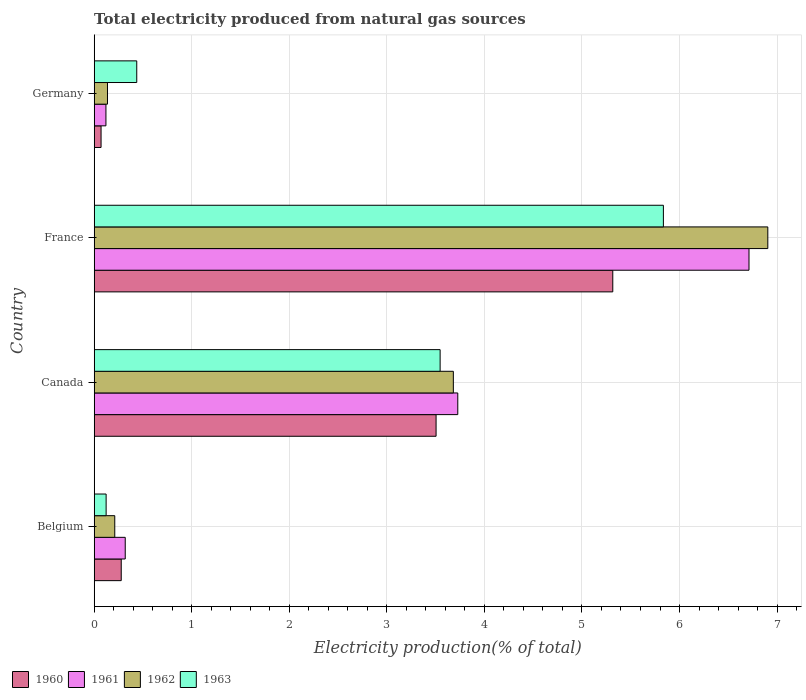Are the number of bars per tick equal to the number of legend labels?
Give a very brief answer. Yes. Are the number of bars on each tick of the Y-axis equal?
Provide a short and direct response. Yes. How many bars are there on the 3rd tick from the top?
Provide a short and direct response. 4. What is the total electricity produced in 1960 in Belgium?
Your answer should be very brief. 0.28. Across all countries, what is the maximum total electricity produced in 1960?
Your answer should be very brief. 5.32. Across all countries, what is the minimum total electricity produced in 1961?
Give a very brief answer. 0.12. In which country was the total electricity produced in 1961 maximum?
Give a very brief answer. France. In which country was the total electricity produced in 1963 minimum?
Keep it short and to the point. Belgium. What is the total total electricity produced in 1963 in the graph?
Make the answer very short. 9.94. What is the difference between the total electricity produced in 1960 in Belgium and that in Canada?
Keep it short and to the point. -3.23. What is the difference between the total electricity produced in 1961 in France and the total electricity produced in 1963 in Canada?
Make the answer very short. 3.17. What is the average total electricity produced in 1960 per country?
Your response must be concise. 2.29. What is the difference between the total electricity produced in 1961 and total electricity produced in 1960 in Germany?
Provide a succinct answer. 0.05. What is the ratio of the total electricity produced in 1962 in Belgium to that in Canada?
Provide a succinct answer. 0.06. What is the difference between the highest and the second highest total electricity produced in 1960?
Provide a succinct answer. 1.81. What is the difference between the highest and the lowest total electricity produced in 1960?
Ensure brevity in your answer.  5.25. Is the sum of the total electricity produced in 1962 in Canada and Germany greater than the maximum total electricity produced in 1960 across all countries?
Ensure brevity in your answer.  No. Is it the case that in every country, the sum of the total electricity produced in 1960 and total electricity produced in 1961 is greater than the sum of total electricity produced in 1962 and total electricity produced in 1963?
Keep it short and to the point. No. What does the 4th bar from the bottom in Belgium represents?
Offer a terse response. 1963. Is it the case that in every country, the sum of the total electricity produced in 1962 and total electricity produced in 1960 is greater than the total electricity produced in 1961?
Keep it short and to the point. Yes. How many bars are there?
Provide a short and direct response. 16. What is the difference between two consecutive major ticks on the X-axis?
Provide a short and direct response. 1. Are the values on the major ticks of X-axis written in scientific E-notation?
Ensure brevity in your answer.  No. How many legend labels are there?
Offer a very short reply. 4. How are the legend labels stacked?
Your response must be concise. Horizontal. What is the title of the graph?
Your answer should be compact. Total electricity produced from natural gas sources. What is the label or title of the Y-axis?
Provide a short and direct response. Country. What is the Electricity production(% of total) in 1960 in Belgium?
Your response must be concise. 0.28. What is the Electricity production(% of total) of 1961 in Belgium?
Your response must be concise. 0.32. What is the Electricity production(% of total) in 1962 in Belgium?
Your response must be concise. 0.21. What is the Electricity production(% of total) in 1963 in Belgium?
Your answer should be very brief. 0.12. What is the Electricity production(% of total) of 1960 in Canada?
Ensure brevity in your answer.  3.5. What is the Electricity production(% of total) of 1961 in Canada?
Ensure brevity in your answer.  3.73. What is the Electricity production(% of total) of 1962 in Canada?
Provide a short and direct response. 3.68. What is the Electricity production(% of total) in 1963 in Canada?
Your answer should be compact. 3.55. What is the Electricity production(% of total) of 1960 in France?
Make the answer very short. 5.32. What is the Electricity production(% of total) of 1961 in France?
Offer a very short reply. 6.71. What is the Electricity production(% of total) of 1962 in France?
Your response must be concise. 6.91. What is the Electricity production(% of total) of 1963 in France?
Provide a short and direct response. 5.83. What is the Electricity production(% of total) in 1960 in Germany?
Your answer should be very brief. 0.07. What is the Electricity production(% of total) in 1961 in Germany?
Your answer should be compact. 0.12. What is the Electricity production(% of total) in 1962 in Germany?
Your answer should be very brief. 0.14. What is the Electricity production(% of total) in 1963 in Germany?
Give a very brief answer. 0.44. Across all countries, what is the maximum Electricity production(% of total) of 1960?
Ensure brevity in your answer.  5.32. Across all countries, what is the maximum Electricity production(% of total) of 1961?
Your answer should be very brief. 6.71. Across all countries, what is the maximum Electricity production(% of total) of 1962?
Your response must be concise. 6.91. Across all countries, what is the maximum Electricity production(% of total) of 1963?
Offer a terse response. 5.83. Across all countries, what is the minimum Electricity production(% of total) of 1960?
Provide a short and direct response. 0.07. Across all countries, what is the minimum Electricity production(% of total) of 1961?
Offer a terse response. 0.12. Across all countries, what is the minimum Electricity production(% of total) of 1962?
Ensure brevity in your answer.  0.14. Across all countries, what is the minimum Electricity production(% of total) in 1963?
Provide a short and direct response. 0.12. What is the total Electricity production(% of total) of 1960 in the graph?
Provide a short and direct response. 9.17. What is the total Electricity production(% of total) in 1961 in the graph?
Give a very brief answer. 10.88. What is the total Electricity production(% of total) of 1962 in the graph?
Your answer should be compact. 10.93. What is the total Electricity production(% of total) of 1963 in the graph?
Provide a succinct answer. 9.94. What is the difference between the Electricity production(% of total) of 1960 in Belgium and that in Canada?
Offer a terse response. -3.23. What is the difference between the Electricity production(% of total) of 1961 in Belgium and that in Canada?
Offer a very short reply. -3.41. What is the difference between the Electricity production(% of total) of 1962 in Belgium and that in Canada?
Offer a very short reply. -3.47. What is the difference between the Electricity production(% of total) in 1963 in Belgium and that in Canada?
Make the answer very short. -3.42. What is the difference between the Electricity production(% of total) of 1960 in Belgium and that in France?
Provide a succinct answer. -5.04. What is the difference between the Electricity production(% of total) of 1961 in Belgium and that in France?
Provide a short and direct response. -6.39. What is the difference between the Electricity production(% of total) of 1962 in Belgium and that in France?
Make the answer very short. -6.69. What is the difference between the Electricity production(% of total) of 1963 in Belgium and that in France?
Make the answer very short. -5.71. What is the difference between the Electricity production(% of total) in 1960 in Belgium and that in Germany?
Your response must be concise. 0.21. What is the difference between the Electricity production(% of total) in 1961 in Belgium and that in Germany?
Provide a succinct answer. 0.2. What is the difference between the Electricity production(% of total) of 1962 in Belgium and that in Germany?
Make the answer very short. 0.07. What is the difference between the Electricity production(% of total) in 1963 in Belgium and that in Germany?
Offer a very short reply. -0.31. What is the difference between the Electricity production(% of total) of 1960 in Canada and that in France?
Give a very brief answer. -1.81. What is the difference between the Electricity production(% of total) in 1961 in Canada and that in France?
Make the answer very short. -2.99. What is the difference between the Electricity production(% of total) of 1962 in Canada and that in France?
Offer a terse response. -3.22. What is the difference between the Electricity production(% of total) in 1963 in Canada and that in France?
Keep it short and to the point. -2.29. What is the difference between the Electricity production(% of total) of 1960 in Canada and that in Germany?
Your answer should be very brief. 3.43. What is the difference between the Electricity production(% of total) in 1961 in Canada and that in Germany?
Provide a short and direct response. 3.61. What is the difference between the Electricity production(% of total) of 1962 in Canada and that in Germany?
Offer a terse response. 3.55. What is the difference between the Electricity production(% of total) in 1963 in Canada and that in Germany?
Offer a terse response. 3.11. What is the difference between the Electricity production(% of total) of 1960 in France and that in Germany?
Your response must be concise. 5.25. What is the difference between the Electricity production(% of total) of 1961 in France and that in Germany?
Your answer should be compact. 6.59. What is the difference between the Electricity production(% of total) in 1962 in France and that in Germany?
Provide a short and direct response. 6.77. What is the difference between the Electricity production(% of total) of 1963 in France and that in Germany?
Keep it short and to the point. 5.4. What is the difference between the Electricity production(% of total) in 1960 in Belgium and the Electricity production(% of total) in 1961 in Canada?
Make the answer very short. -3.45. What is the difference between the Electricity production(% of total) in 1960 in Belgium and the Electricity production(% of total) in 1962 in Canada?
Provide a succinct answer. -3.4. What is the difference between the Electricity production(% of total) of 1960 in Belgium and the Electricity production(% of total) of 1963 in Canada?
Keep it short and to the point. -3.27. What is the difference between the Electricity production(% of total) of 1961 in Belgium and the Electricity production(% of total) of 1962 in Canada?
Provide a short and direct response. -3.36. What is the difference between the Electricity production(% of total) in 1961 in Belgium and the Electricity production(% of total) in 1963 in Canada?
Provide a succinct answer. -3.23. What is the difference between the Electricity production(% of total) in 1962 in Belgium and the Electricity production(% of total) in 1963 in Canada?
Your answer should be very brief. -3.34. What is the difference between the Electricity production(% of total) in 1960 in Belgium and the Electricity production(% of total) in 1961 in France?
Provide a succinct answer. -6.43. What is the difference between the Electricity production(% of total) of 1960 in Belgium and the Electricity production(% of total) of 1962 in France?
Provide a succinct answer. -6.63. What is the difference between the Electricity production(% of total) of 1960 in Belgium and the Electricity production(% of total) of 1963 in France?
Offer a very short reply. -5.56. What is the difference between the Electricity production(% of total) of 1961 in Belgium and the Electricity production(% of total) of 1962 in France?
Keep it short and to the point. -6.59. What is the difference between the Electricity production(% of total) of 1961 in Belgium and the Electricity production(% of total) of 1963 in France?
Provide a short and direct response. -5.52. What is the difference between the Electricity production(% of total) in 1962 in Belgium and the Electricity production(% of total) in 1963 in France?
Give a very brief answer. -5.62. What is the difference between the Electricity production(% of total) in 1960 in Belgium and the Electricity production(% of total) in 1961 in Germany?
Ensure brevity in your answer.  0.16. What is the difference between the Electricity production(% of total) of 1960 in Belgium and the Electricity production(% of total) of 1962 in Germany?
Make the answer very short. 0.14. What is the difference between the Electricity production(% of total) of 1960 in Belgium and the Electricity production(% of total) of 1963 in Germany?
Ensure brevity in your answer.  -0.16. What is the difference between the Electricity production(% of total) of 1961 in Belgium and the Electricity production(% of total) of 1962 in Germany?
Make the answer very short. 0.18. What is the difference between the Electricity production(% of total) in 1961 in Belgium and the Electricity production(% of total) in 1963 in Germany?
Give a very brief answer. -0.12. What is the difference between the Electricity production(% of total) in 1962 in Belgium and the Electricity production(% of total) in 1963 in Germany?
Your answer should be very brief. -0.23. What is the difference between the Electricity production(% of total) in 1960 in Canada and the Electricity production(% of total) in 1961 in France?
Your answer should be very brief. -3.21. What is the difference between the Electricity production(% of total) of 1960 in Canada and the Electricity production(% of total) of 1962 in France?
Your answer should be compact. -3.4. What is the difference between the Electricity production(% of total) of 1960 in Canada and the Electricity production(% of total) of 1963 in France?
Your answer should be very brief. -2.33. What is the difference between the Electricity production(% of total) in 1961 in Canada and the Electricity production(% of total) in 1962 in France?
Your response must be concise. -3.18. What is the difference between the Electricity production(% of total) in 1961 in Canada and the Electricity production(% of total) in 1963 in France?
Make the answer very short. -2.11. What is the difference between the Electricity production(% of total) of 1962 in Canada and the Electricity production(% of total) of 1963 in France?
Provide a succinct answer. -2.15. What is the difference between the Electricity production(% of total) of 1960 in Canada and the Electricity production(% of total) of 1961 in Germany?
Give a very brief answer. 3.38. What is the difference between the Electricity production(% of total) in 1960 in Canada and the Electricity production(% of total) in 1962 in Germany?
Give a very brief answer. 3.37. What is the difference between the Electricity production(% of total) in 1960 in Canada and the Electricity production(% of total) in 1963 in Germany?
Offer a very short reply. 3.07. What is the difference between the Electricity production(% of total) of 1961 in Canada and the Electricity production(% of total) of 1962 in Germany?
Keep it short and to the point. 3.59. What is the difference between the Electricity production(% of total) in 1961 in Canada and the Electricity production(% of total) in 1963 in Germany?
Ensure brevity in your answer.  3.29. What is the difference between the Electricity production(% of total) of 1962 in Canada and the Electricity production(% of total) of 1963 in Germany?
Your response must be concise. 3.25. What is the difference between the Electricity production(% of total) in 1960 in France and the Electricity production(% of total) in 1961 in Germany?
Ensure brevity in your answer.  5.2. What is the difference between the Electricity production(% of total) of 1960 in France and the Electricity production(% of total) of 1962 in Germany?
Offer a terse response. 5.18. What is the difference between the Electricity production(% of total) of 1960 in France and the Electricity production(% of total) of 1963 in Germany?
Your answer should be compact. 4.88. What is the difference between the Electricity production(% of total) of 1961 in France and the Electricity production(% of total) of 1962 in Germany?
Keep it short and to the point. 6.58. What is the difference between the Electricity production(% of total) in 1961 in France and the Electricity production(% of total) in 1963 in Germany?
Provide a short and direct response. 6.28. What is the difference between the Electricity production(% of total) in 1962 in France and the Electricity production(% of total) in 1963 in Germany?
Offer a terse response. 6.47. What is the average Electricity production(% of total) in 1960 per country?
Your answer should be compact. 2.29. What is the average Electricity production(% of total) in 1961 per country?
Your answer should be very brief. 2.72. What is the average Electricity production(% of total) of 1962 per country?
Make the answer very short. 2.73. What is the average Electricity production(% of total) of 1963 per country?
Your response must be concise. 2.48. What is the difference between the Electricity production(% of total) in 1960 and Electricity production(% of total) in 1961 in Belgium?
Offer a very short reply. -0.04. What is the difference between the Electricity production(% of total) in 1960 and Electricity production(% of total) in 1962 in Belgium?
Keep it short and to the point. 0.07. What is the difference between the Electricity production(% of total) in 1960 and Electricity production(% of total) in 1963 in Belgium?
Ensure brevity in your answer.  0.15. What is the difference between the Electricity production(% of total) in 1961 and Electricity production(% of total) in 1962 in Belgium?
Offer a very short reply. 0.11. What is the difference between the Electricity production(% of total) of 1961 and Electricity production(% of total) of 1963 in Belgium?
Provide a short and direct response. 0.2. What is the difference between the Electricity production(% of total) in 1962 and Electricity production(% of total) in 1963 in Belgium?
Keep it short and to the point. 0.09. What is the difference between the Electricity production(% of total) of 1960 and Electricity production(% of total) of 1961 in Canada?
Ensure brevity in your answer.  -0.22. What is the difference between the Electricity production(% of total) of 1960 and Electricity production(% of total) of 1962 in Canada?
Provide a succinct answer. -0.18. What is the difference between the Electricity production(% of total) of 1960 and Electricity production(% of total) of 1963 in Canada?
Provide a short and direct response. -0.04. What is the difference between the Electricity production(% of total) of 1961 and Electricity production(% of total) of 1962 in Canada?
Offer a terse response. 0.05. What is the difference between the Electricity production(% of total) of 1961 and Electricity production(% of total) of 1963 in Canada?
Offer a very short reply. 0.18. What is the difference between the Electricity production(% of total) in 1962 and Electricity production(% of total) in 1963 in Canada?
Your response must be concise. 0.14. What is the difference between the Electricity production(% of total) in 1960 and Electricity production(% of total) in 1961 in France?
Keep it short and to the point. -1.4. What is the difference between the Electricity production(% of total) in 1960 and Electricity production(% of total) in 1962 in France?
Ensure brevity in your answer.  -1.59. What is the difference between the Electricity production(% of total) in 1960 and Electricity production(% of total) in 1963 in France?
Ensure brevity in your answer.  -0.52. What is the difference between the Electricity production(% of total) in 1961 and Electricity production(% of total) in 1962 in France?
Keep it short and to the point. -0.19. What is the difference between the Electricity production(% of total) in 1961 and Electricity production(% of total) in 1963 in France?
Provide a short and direct response. 0.88. What is the difference between the Electricity production(% of total) of 1962 and Electricity production(% of total) of 1963 in France?
Your response must be concise. 1.07. What is the difference between the Electricity production(% of total) in 1960 and Electricity production(% of total) in 1961 in Germany?
Ensure brevity in your answer.  -0.05. What is the difference between the Electricity production(% of total) in 1960 and Electricity production(% of total) in 1962 in Germany?
Your answer should be compact. -0.07. What is the difference between the Electricity production(% of total) in 1960 and Electricity production(% of total) in 1963 in Germany?
Provide a succinct answer. -0.37. What is the difference between the Electricity production(% of total) in 1961 and Electricity production(% of total) in 1962 in Germany?
Keep it short and to the point. -0.02. What is the difference between the Electricity production(% of total) in 1961 and Electricity production(% of total) in 1963 in Germany?
Your answer should be very brief. -0.32. What is the difference between the Electricity production(% of total) of 1962 and Electricity production(% of total) of 1963 in Germany?
Your answer should be very brief. -0.3. What is the ratio of the Electricity production(% of total) in 1960 in Belgium to that in Canada?
Your response must be concise. 0.08. What is the ratio of the Electricity production(% of total) in 1961 in Belgium to that in Canada?
Give a very brief answer. 0.09. What is the ratio of the Electricity production(% of total) of 1962 in Belgium to that in Canada?
Provide a succinct answer. 0.06. What is the ratio of the Electricity production(% of total) of 1963 in Belgium to that in Canada?
Keep it short and to the point. 0.03. What is the ratio of the Electricity production(% of total) of 1960 in Belgium to that in France?
Your response must be concise. 0.05. What is the ratio of the Electricity production(% of total) in 1961 in Belgium to that in France?
Your response must be concise. 0.05. What is the ratio of the Electricity production(% of total) in 1962 in Belgium to that in France?
Give a very brief answer. 0.03. What is the ratio of the Electricity production(% of total) of 1963 in Belgium to that in France?
Keep it short and to the point. 0.02. What is the ratio of the Electricity production(% of total) in 1960 in Belgium to that in Germany?
Provide a succinct answer. 3.94. What is the ratio of the Electricity production(% of total) of 1961 in Belgium to that in Germany?
Offer a terse response. 2.64. What is the ratio of the Electricity production(% of total) of 1962 in Belgium to that in Germany?
Offer a very short reply. 1.55. What is the ratio of the Electricity production(% of total) of 1963 in Belgium to that in Germany?
Make the answer very short. 0.28. What is the ratio of the Electricity production(% of total) in 1960 in Canada to that in France?
Your answer should be compact. 0.66. What is the ratio of the Electricity production(% of total) in 1961 in Canada to that in France?
Your response must be concise. 0.56. What is the ratio of the Electricity production(% of total) of 1962 in Canada to that in France?
Provide a short and direct response. 0.53. What is the ratio of the Electricity production(% of total) of 1963 in Canada to that in France?
Your answer should be compact. 0.61. What is the ratio of the Electricity production(% of total) of 1960 in Canada to that in Germany?
Ensure brevity in your answer.  49.85. What is the ratio of the Electricity production(% of total) of 1961 in Canada to that in Germany?
Keep it short and to the point. 30.98. What is the ratio of the Electricity production(% of total) in 1962 in Canada to that in Germany?
Ensure brevity in your answer.  27.02. What is the ratio of the Electricity production(% of total) in 1963 in Canada to that in Germany?
Offer a very short reply. 8.13. What is the ratio of the Electricity production(% of total) in 1960 in France to that in Germany?
Keep it short and to the point. 75.62. What is the ratio of the Electricity production(% of total) in 1961 in France to that in Germany?
Offer a very short reply. 55.79. What is the ratio of the Electricity production(% of total) of 1962 in France to that in Germany?
Keep it short and to the point. 50.69. What is the ratio of the Electricity production(% of total) in 1963 in France to that in Germany?
Offer a terse response. 13.38. What is the difference between the highest and the second highest Electricity production(% of total) in 1960?
Keep it short and to the point. 1.81. What is the difference between the highest and the second highest Electricity production(% of total) of 1961?
Make the answer very short. 2.99. What is the difference between the highest and the second highest Electricity production(% of total) of 1962?
Keep it short and to the point. 3.22. What is the difference between the highest and the second highest Electricity production(% of total) of 1963?
Your answer should be very brief. 2.29. What is the difference between the highest and the lowest Electricity production(% of total) of 1960?
Provide a short and direct response. 5.25. What is the difference between the highest and the lowest Electricity production(% of total) of 1961?
Give a very brief answer. 6.59. What is the difference between the highest and the lowest Electricity production(% of total) in 1962?
Offer a terse response. 6.77. What is the difference between the highest and the lowest Electricity production(% of total) of 1963?
Provide a succinct answer. 5.71. 